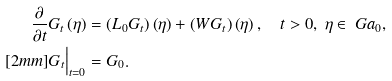<formula> <loc_0><loc_0><loc_500><loc_500>\frac { \partial } { \partial t } G _ { t } \left ( \eta \right ) & = \left ( L _ { 0 } G _ { t } \right ) \left ( \eta \right ) + \left ( W G _ { t } \right ) \left ( \eta \right ) , \quad t > 0 , \ \eta \in \ G a _ { 0 } , \\ [ 2 m m ] G _ { t } \Big | _ { t = 0 } & = G _ { 0 } .</formula> 